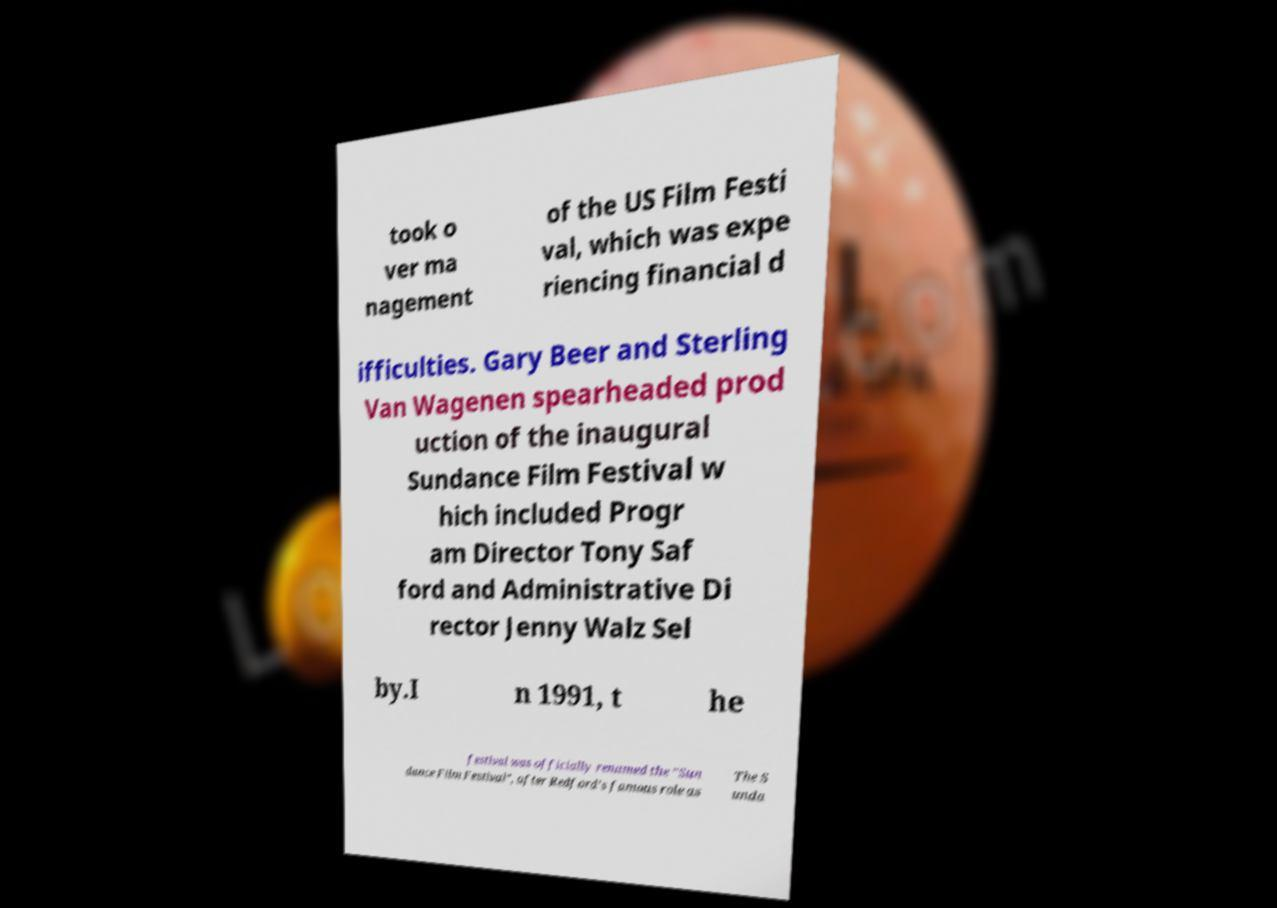For documentation purposes, I need the text within this image transcribed. Could you provide that? took o ver ma nagement of the US Film Festi val, which was expe riencing financial d ifficulties. Gary Beer and Sterling Van Wagenen spearheaded prod uction of the inaugural Sundance Film Festival w hich included Progr am Director Tony Saf ford and Administrative Di rector Jenny Walz Sel by.I n 1991, t he festival was officially renamed the "Sun dance Film Festival", after Redford's famous role as The S unda 